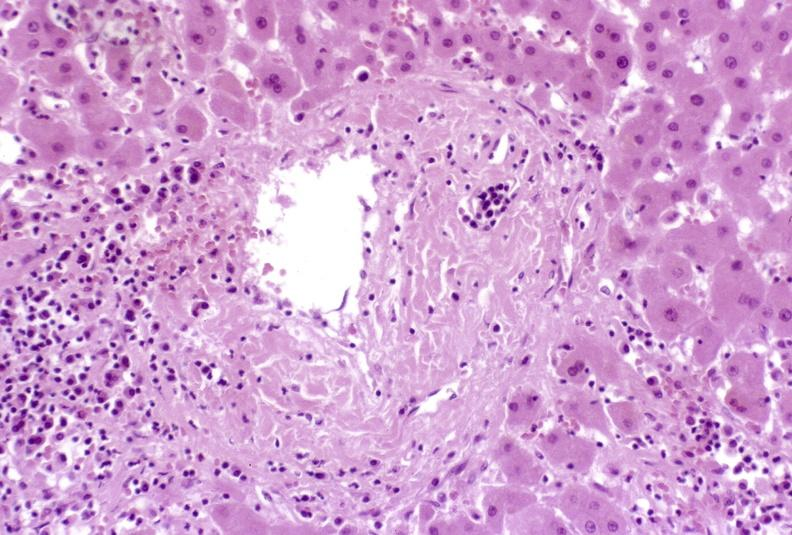what is present?
Answer the question using a single word or phrase. Liver 